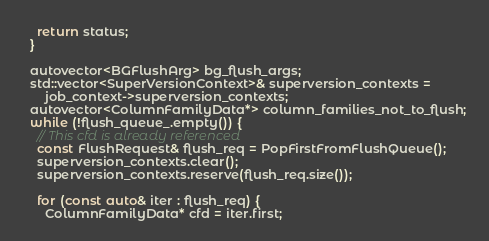<code> <loc_0><loc_0><loc_500><loc_500><_C++_>    return status;
  }

  autovector<BGFlushArg> bg_flush_args;
  std::vector<SuperVersionContext>& superversion_contexts =
      job_context->superversion_contexts;
  autovector<ColumnFamilyData*> column_families_not_to_flush;
  while (!flush_queue_.empty()) {
    // This cfd is already referenced
    const FlushRequest& flush_req = PopFirstFromFlushQueue();
    superversion_contexts.clear();
    superversion_contexts.reserve(flush_req.size());

    for (const auto& iter : flush_req) {
      ColumnFamilyData* cfd = iter.first;</code> 